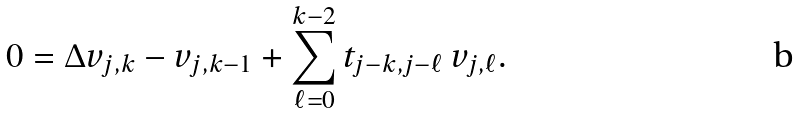<formula> <loc_0><loc_0><loc_500><loc_500>0 = \Delta v _ { j , k } - v _ { j , k - 1 } + \sum _ { \ell = 0 } ^ { k - 2 } t _ { j - k , j - \ell } \, v _ { j , \ell } .</formula> 